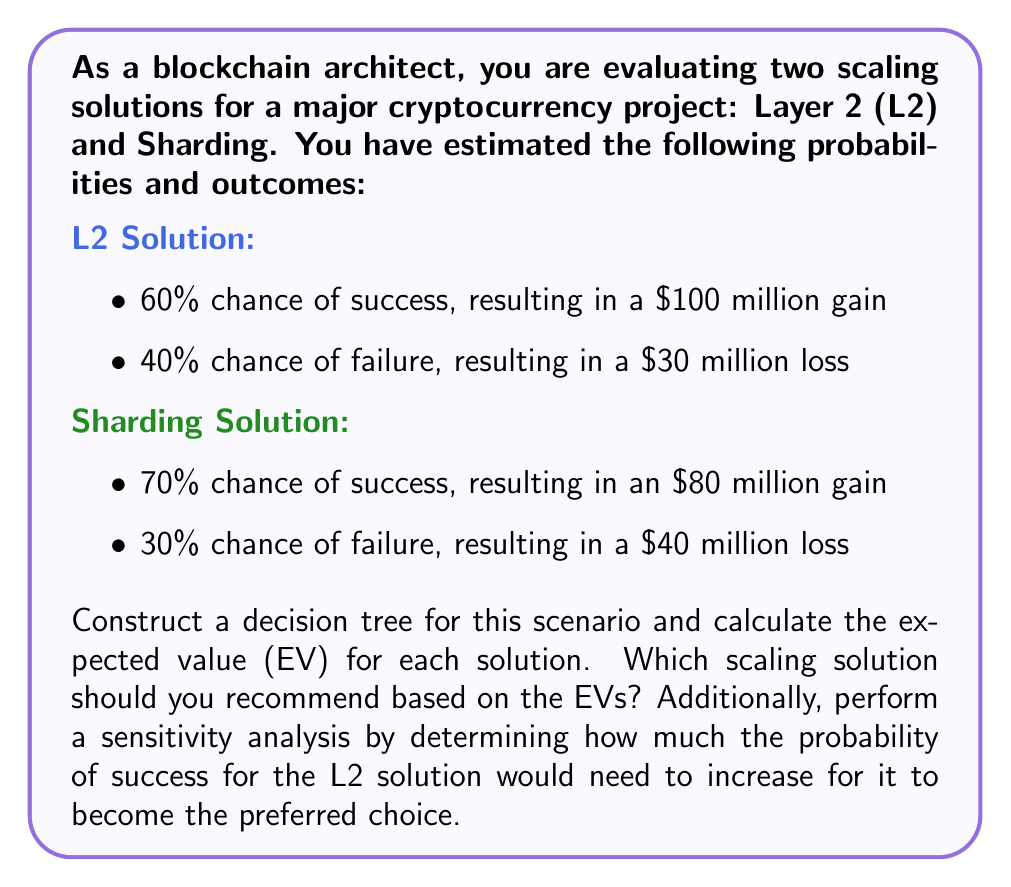Help me with this question. Let's approach this problem step by step:

1. Construct the decision tree:

[asy]
unitsize(1cm);

draw((0,0)--(2,1), arrow=Arrow);
draw((0,0)--(2,-1), arrow=Arrow);

draw((2,1)--(4,1.5), arrow=Arrow);
draw((2,1)--(4,0.5), arrow=Arrow);
draw((2,-1)--(4,-0.5), arrow=Arrow);
draw((2,-1)--(4,-1.5), arrow=Arrow);

label("L2", (1,0.5), E);
label("Sharding", (1,-0.5), E);

label("Success (60%)", (3,1.25), N);
label("Failure (40%)", (3,0.75), S);
label("Success (70%)", (3,-0.75), N);
label("Failure (30%)", (3,-1.25), S);

label("$100M", (4,1.5), E);
label("$-30M", (4,0.5), E);
label("$80M", (4,-0.5), E);
label("$-40M", (4,-1.5), E);
[/asy]

2. Calculate the Expected Value (EV) for each solution:

For L2 Solution:
$$ EV_{L2} = (0.60 \times \$100M) + (0.40 \times (-\$30M)) = \$60M - \$12M = \$48M $$

For Sharding Solution:
$$ EV_{Sharding} = (0.70 \times \$80M) + (0.30 \times (-\$40M)) = \$56M - \$12M = \$44M $$

3. Compare the EVs:
The L2 solution has a higher EV ($48M vs $44M), so it should be recommended based on these calculations.

4. Sensitivity Analysis:
To determine how much the probability of success for the L2 solution needs to increase to become the preferred choice, we need to set up an equation where the EV of L2 equals the EV of Sharding:

Let x be the new probability of success for L2:

$$ x(\$100M) + (1-x)(-\$30M) = \$44M $$

Solving this equation:

$$ 100x - 30 + 30x = 44 $$
$$ 130x = 74 $$
$$ x \approx 0.5692 \text{ or } 56.92\% $$

The current probability of success for L2 is 60%, which is already higher than 56.92%. This means that L2 is already the preferred choice, and no increase in its success probability is needed.
Answer: The L2 scaling solution should be recommended as it has a higher Expected Value of $48 million compared to $44 million for the Sharding solution. The sensitivity analysis shows that the L2 solution is already the preferred choice, and no increase in its success probability is needed for it to remain the better option. 